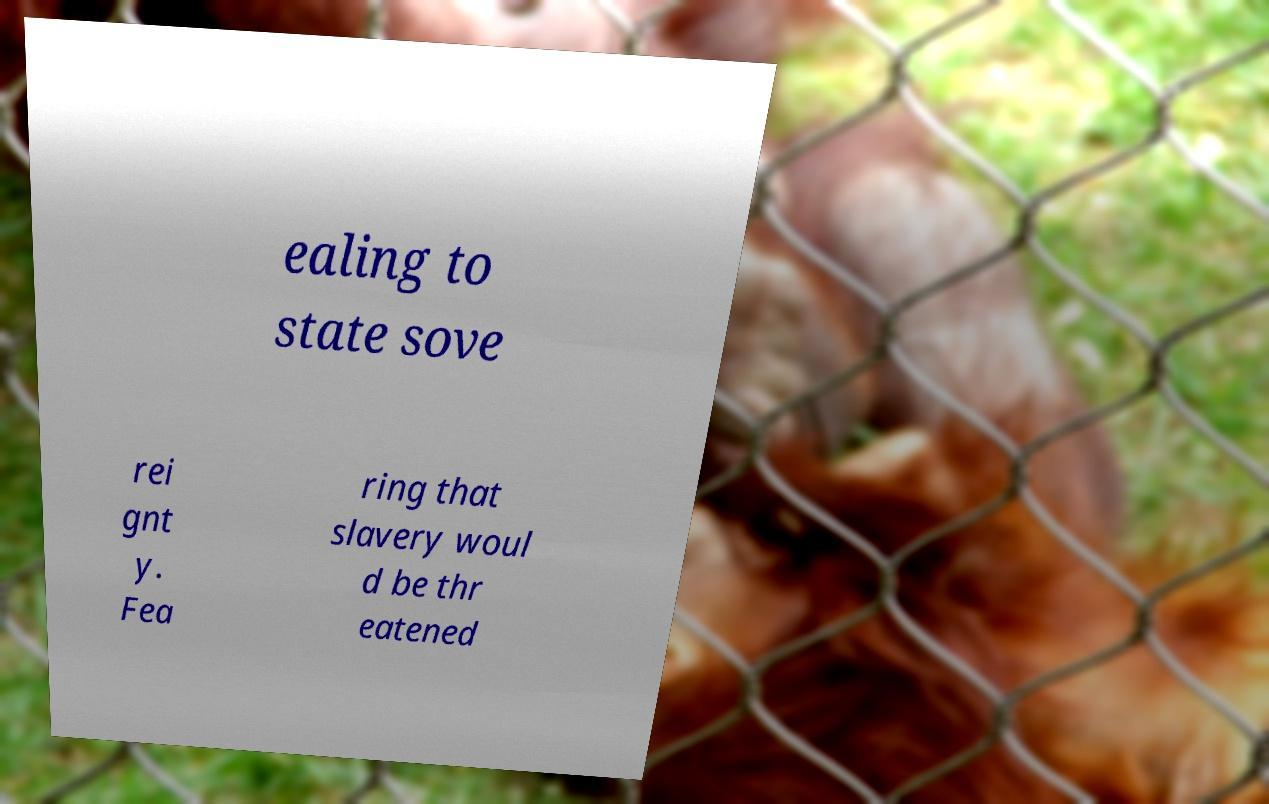Please read and relay the text visible in this image. What does it say? ealing to state sove rei gnt y. Fea ring that slavery woul d be thr eatened 